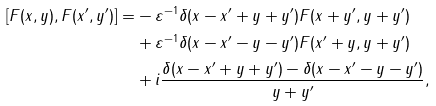<formula> <loc_0><loc_0><loc_500><loc_500>[ F ( x , y ) , F ( x ^ { \prime } , y ^ { \prime } ) ] = & - \varepsilon ^ { - 1 } \delta ( x - x ^ { \prime } + y + y ^ { \prime } ) F ( x + y ^ { \prime } , y + y ^ { \prime } ) \\ & + \varepsilon ^ { - 1 } \delta ( x - x ^ { \prime } - y - y ^ { \prime } ) F ( x ^ { \prime } + y , y + y ^ { \prime } ) \\ & + i \frac { \delta ( x - x ^ { \prime } + y + y ^ { \prime } ) - \delta ( x - x ^ { \prime } - y - y ^ { \prime } ) } { y + y ^ { \prime } } ,</formula> 